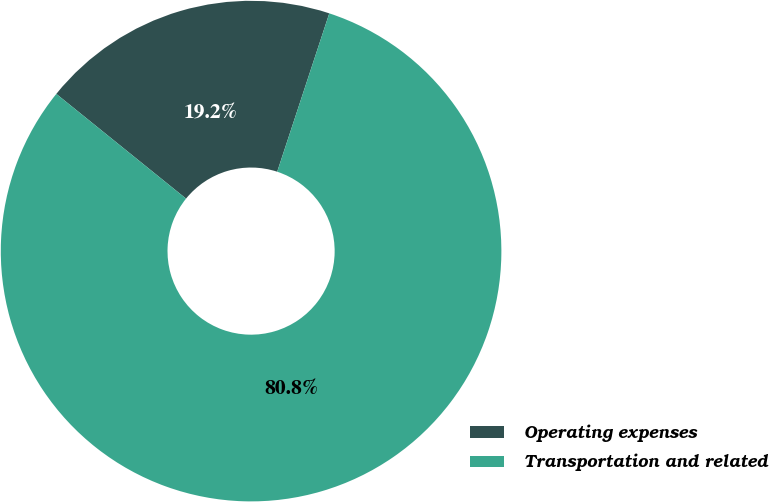Convert chart to OTSL. <chart><loc_0><loc_0><loc_500><loc_500><pie_chart><fcel>Operating expenses<fcel>Transportation and related<nl><fcel>19.25%<fcel>80.75%<nl></chart> 